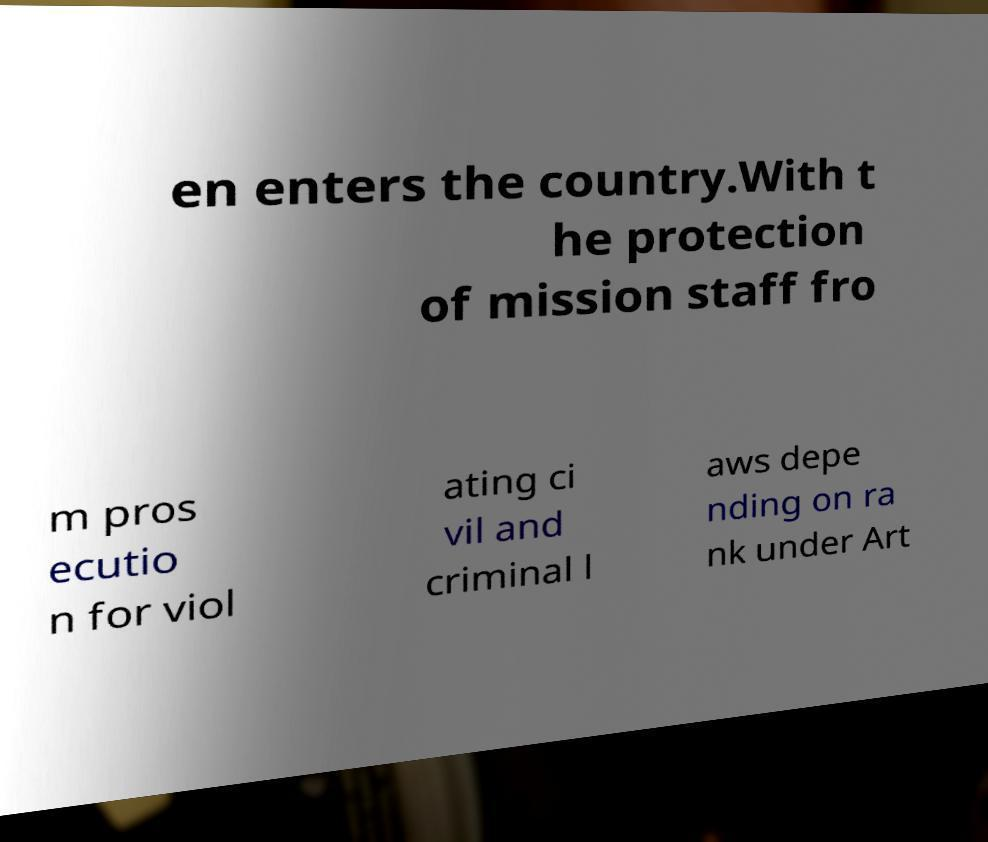Please read and relay the text visible in this image. What does it say? en enters the country.With t he protection of mission staff fro m pros ecutio n for viol ating ci vil and criminal l aws depe nding on ra nk under Art 